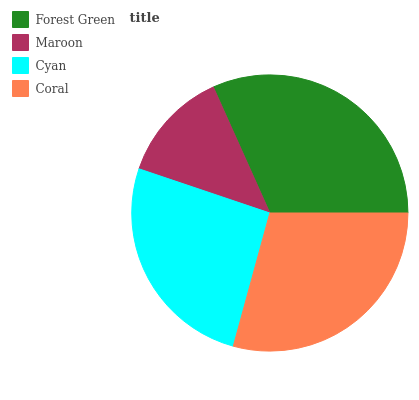Is Maroon the minimum?
Answer yes or no. Yes. Is Forest Green the maximum?
Answer yes or no. Yes. Is Cyan the minimum?
Answer yes or no. No. Is Cyan the maximum?
Answer yes or no. No. Is Cyan greater than Maroon?
Answer yes or no. Yes. Is Maroon less than Cyan?
Answer yes or no. Yes. Is Maroon greater than Cyan?
Answer yes or no. No. Is Cyan less than Maroon?
Answer yes or no. No. Is Coral the high median?
Answer yes or no. Yes. Is Cyan the low median?
Answer yes or no. Yes. Is Forest Green the high median?
Answer yes or no. No. Is Coral the low median?
Answer yes or no. No. 